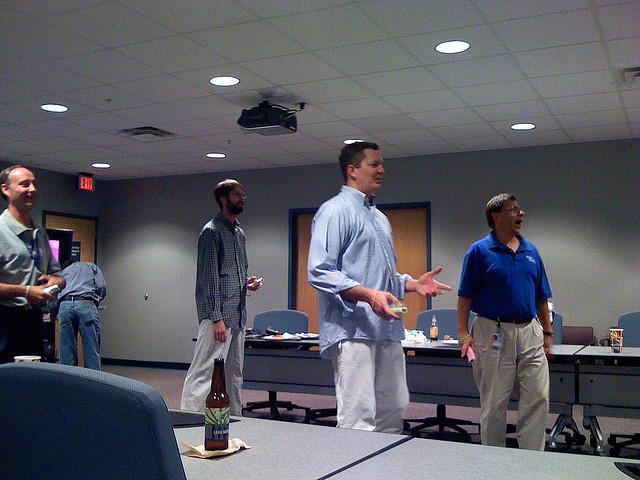What is the purpose of the black object on the ceiling?
Select the accurate answer and provide justification: `Answer: choice
Rationale: srationale.`
Options: Projecting, light, heating, cooling. Answer: projecting.
Rationale: The object on the ceiling is a project and can be used to show movies or games. 